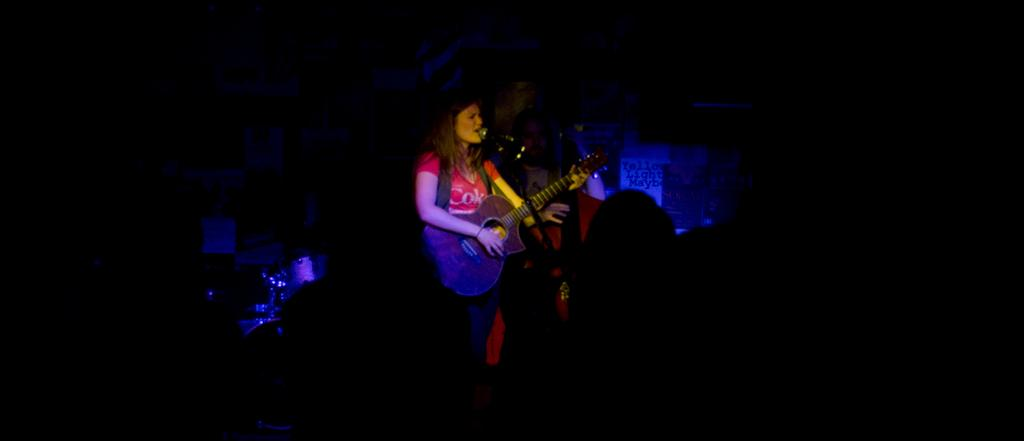Who is the main subject in the image? There is a woman in the image. What is the woman doing in the image? The woman is playing a guitar. What object is present in the image that is typically used for amplifying sound? There is a microphone in the image. How many boats can be seen in the image? There are no boats present in the image. What fact about the woman's pocket can be determined from the image? The image does not provide any information about the woman's pocket, so it cannot be determined from the image. 